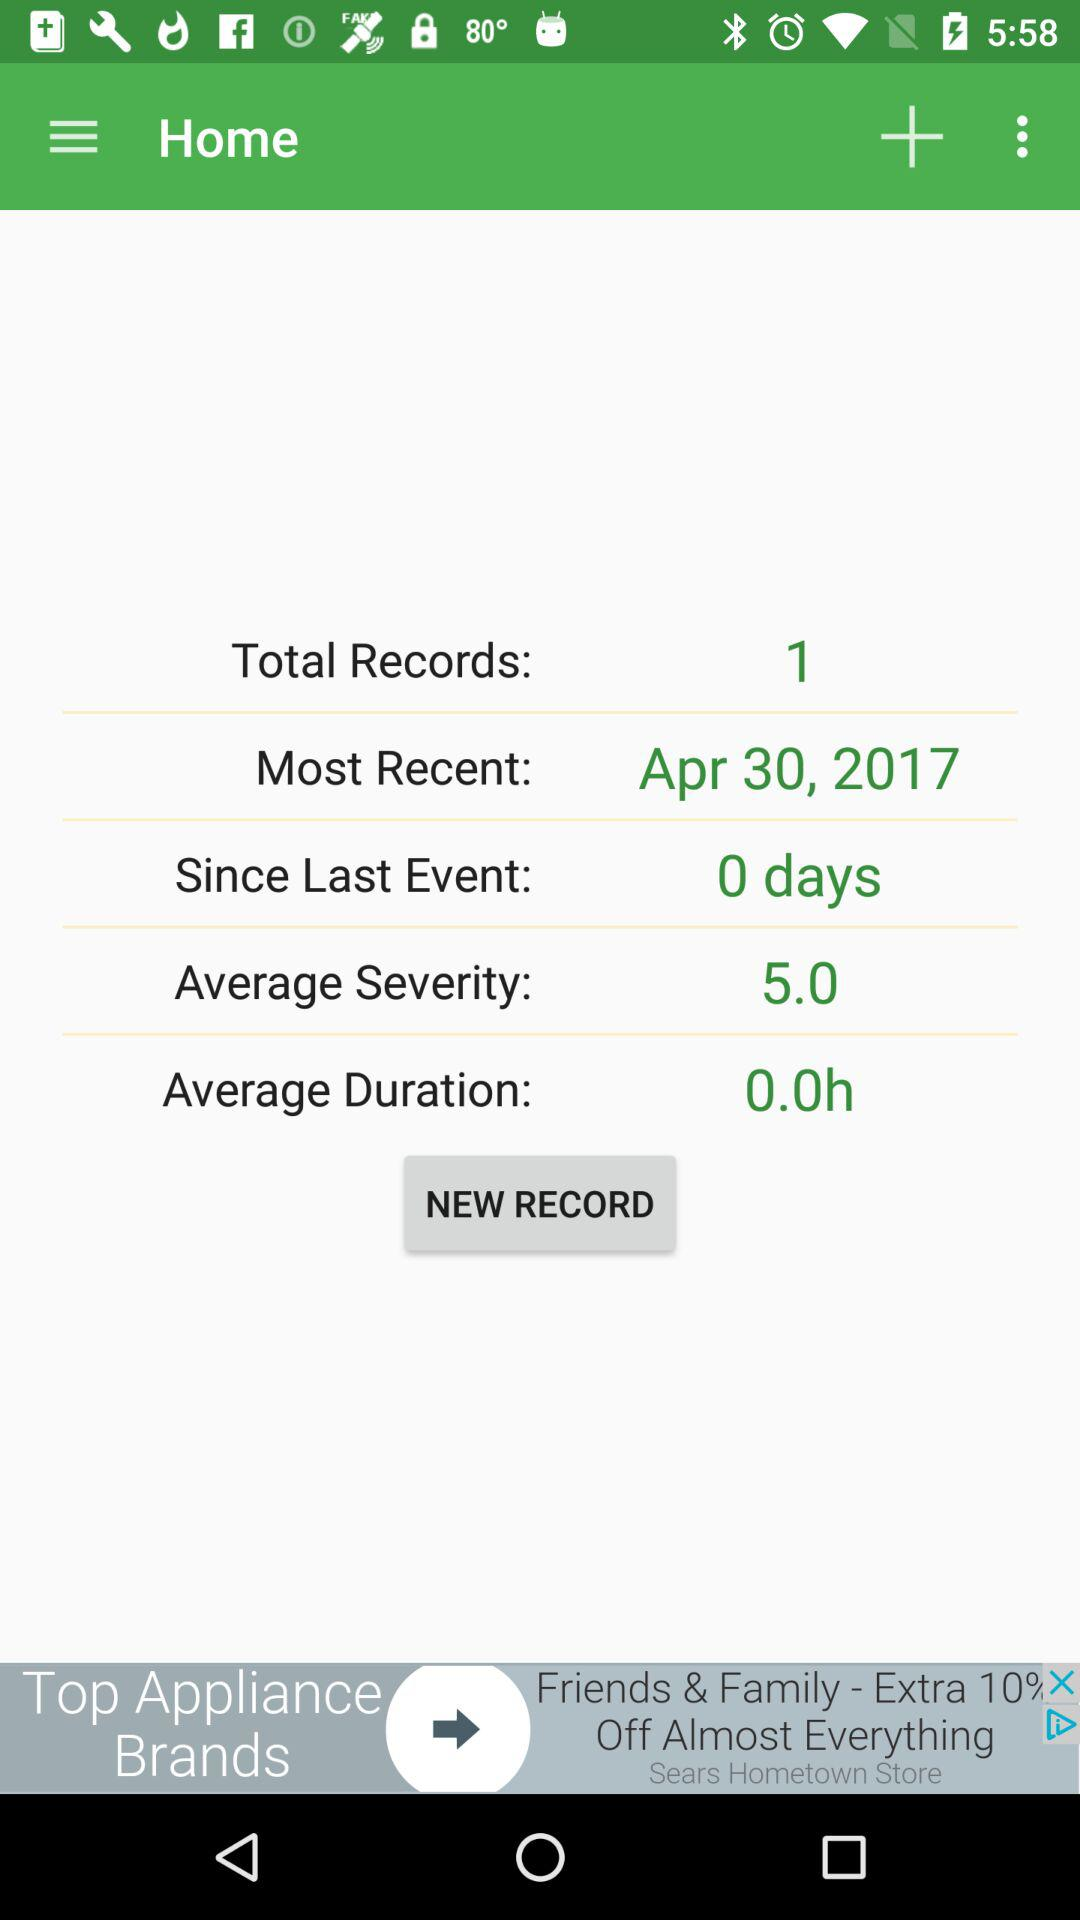How many days have passed since the last event?
Answer the question using a single word or phrase. 0 days 